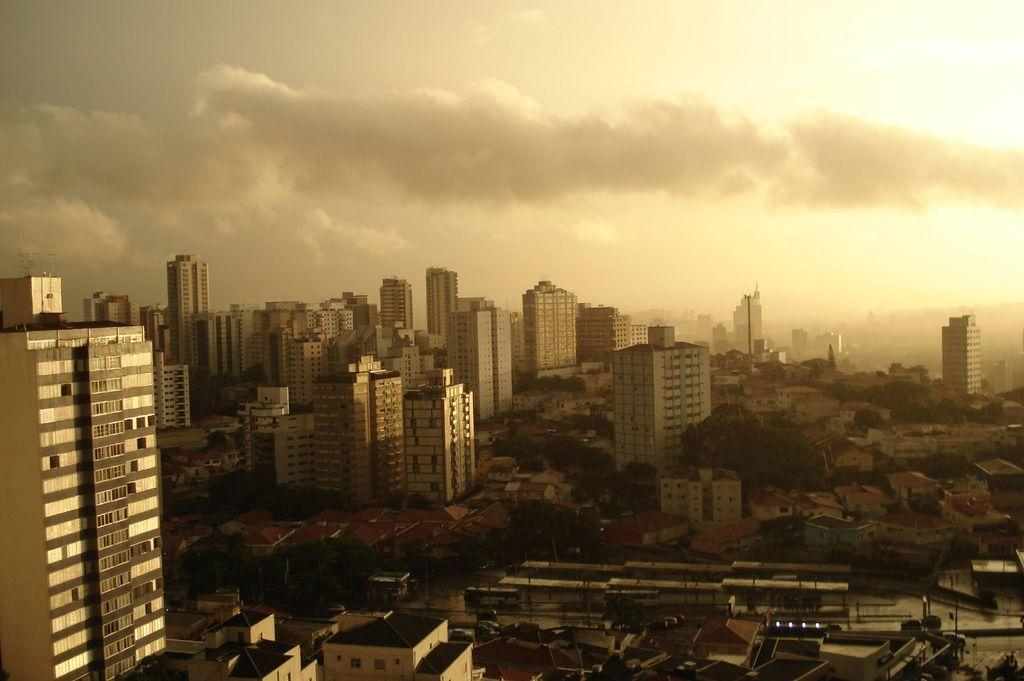What type of view is shown in the image? The image is an aerial view of a city. What structures can be seen in the image? There are buildings and skyscrapers in the image. Are there any natural elements present in the image? Yes, there are trees in the image. What can be observed about the lighting in the image? There are lights visible in the image. How would you describe the sky in the image? The sky is partially cloudy in the image. How many birds are balanced on the hour hand of the clock tower in the image? There is no clock tower or birds present in the image. 